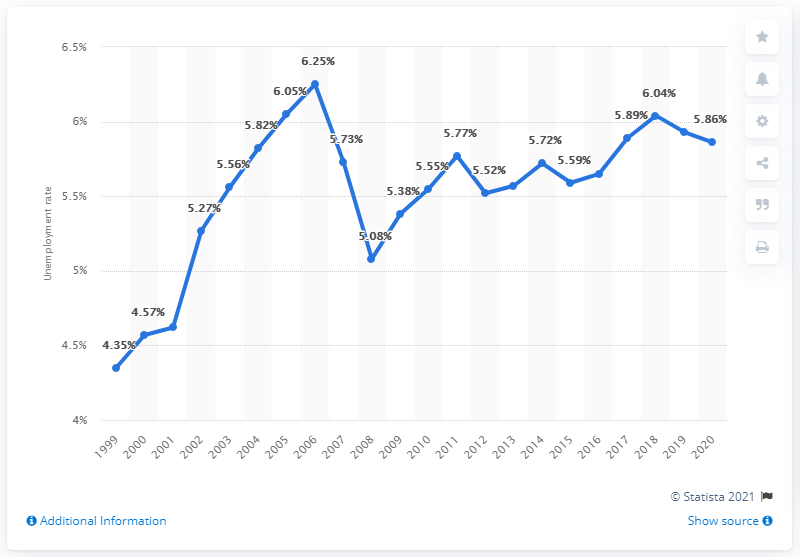Draw attention to some important aspects in this diagram. In 2020, the unemployment rate in Saudi Arabia was 5.86%. 